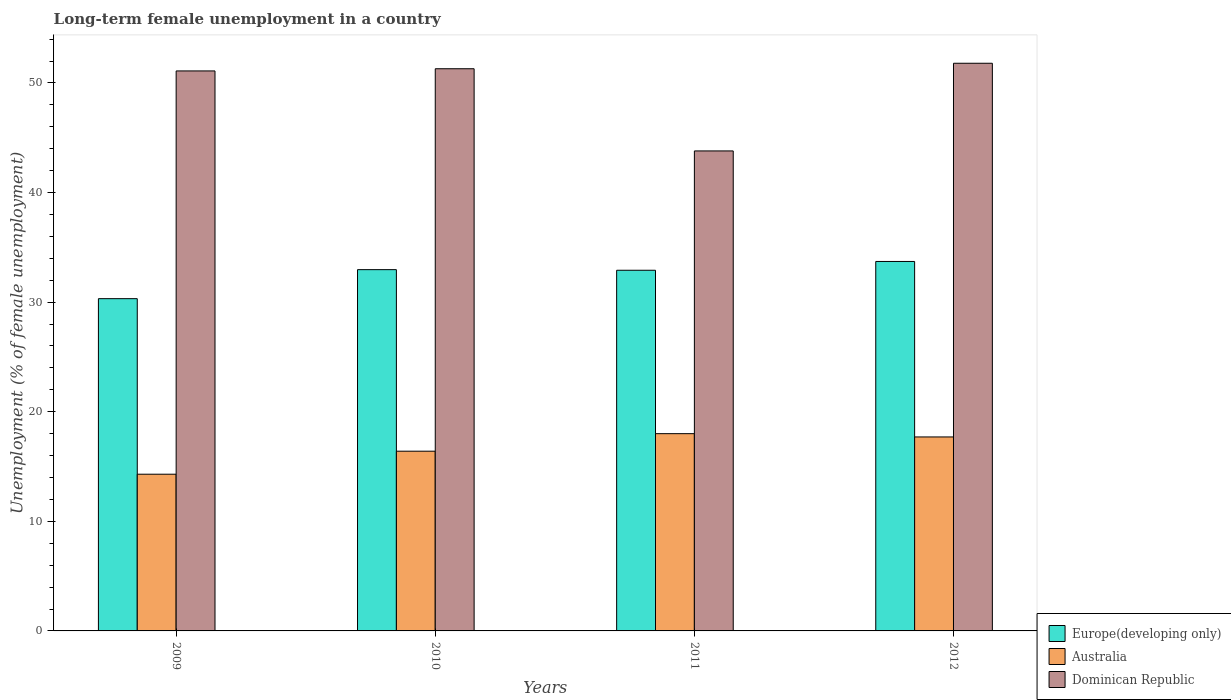How many groups of bars are there?
Provide a succinct answer. 4. Are the number of bars per tick equal to the number of legend labels?
Offer a terse response. Yes. Are the number of bars on each tick of the X-axis equal?
Provide a succinct answer. Yes. How many bars are there on the 3rd tick from the left?
Your answer should be very brief. 3. What is the percentage of long-term unemployed female population in Dominican Republic in 2011?
Give a very brief answer. 43.8. Across all years, what is the maximum percentage of long-term unemployed female population in Australia?
Provide a succinct answer. 18. Across all years, what is the minimum percentage of long-term unemployed female population in Australia?
Offer a terse response. 14.3. In which year was the percentage of long-term unemployed female population in Australia maximum?
Provide a short and direct response. 2011. In which year was the percentage of long-term unemployed female population in Dominican Republic minimum?
Provide a short and direct response. 2011. What is the total percentage of long-term unemployed female population in Dominican Republic in the graph?
Your answer should be very brief. 198. What is the difference between the percentage of long-term unemployed female population in Europe(developing only) in 2009 and that in 2011?
Offer a very short reply. -2.59. What is the difference between the percentage of long-term unemployed female population in Dominican Republic in 2010 and the percentage of long-term unemployed female population in Europe(developing only) in 2012?
Provide a short and direct response. 17.59. What is the average percentage of long-term unemployed female population in Europe(developing only) per year?
Make the answer very short. 32.48. In the year 2011, what is the difference between the percentage of long-term unemployed female population in Dominican Republic and percentage of long-term unemployed female population in Australia?
Offer a very short reply. 25.8. What is the ratio of the percentage of long-term unemployed female population in Europe(developing only) in 2009 to that in 2012?
Your answer should be very brief. 0.9. Is the percentage of long-term unemployed female population in Europe(developing only) in 2009 less than that in 2010?
Your answer should be compact. Yes. What is the difference between the highest and the second highest percentage of long-term unemployed female population in Dominican Republic?
Your answer should be very brief. 0.5. What is the difference between the highest and the lowest percentage of long-term unemployed female population in Europe(developing only)?
Offer a very short reply. 3.4. In how many years, is the percentage of long-term unemployed female population in Australia greater than the average percentage of long-term unemployed female population in Australia taken over all years?
Make the answer very short. 2. Is the sum of the percentage of long-term unemployed female population in Europe(developing only) in 2009 and 2011 greater than the maximum percentage of long-term unemployed female population in Dominican Republic across all years?
Offer a terse response. Yes. What does the 1st bar from the left in 2011 represents?
Give a very brief answer. Europe(developing only). What does the 1st bar from the right in 2012 represents?
Keep it short and to the point. Dominican Republic. Is it the case that in every year, the sum of the percentage of long-term unemployed female population in Australia and percentage of long-term unemployed female population in Dominican Republic is greater than the percentage of long-term unemployed female population in Europe(developing only)?
Give a very brief answer. Yes. How many bars are there?
Provide a short and direct response. 12. Does the graph contain any zero values?
Your answer should be very brief. No. Does the graph contain grids?
Your answer should be compact. No. How many legend labels are there?
Make the answer very short. 3. How are the legend labels stacked?
Provide a succinct answer. Vertical. What is the title of the graph?
Keep it short and to the point. Long-term female unemployment in a country. What is the label or title of the X-axis?
Give a very brief answer. Years. What is the label or title of the Y-axis?
Offer a very short reply. Unemployment (% of female unemployment). What is the Unemployment (% of female unemployment) in Europe(developing only) in 2009?
Your answer should be compact. 30.32. What is the Unemployment (% of female unemployment) in Australia in 2009?
Your answer should be very brief. 14.3. What is the Unemployment (% of female unemployment) of Dominican Republic in 2009?
Offer a very short reply. 51.1. What is the Unemployment (% of female unemployment) of Europe(developing only) in 2010?
Your response must be concise. 32.97. What is the Unemployment (% of female unemployment) of Australia in 2010?
Your response must be concise. 16.4. What is the Unemployment (% of female unemployment) of Dominican Republic in 2010?
Keep it short and to the point. 51.3. What is the Unemployment (% of female unemployment) of Europe(developing only) in 2011?
Offer a terse response. 32.91. What is the Unemployment (% of female unemployment) of Australia in 2011?
Make the answer very short. 18. What is the Unemployment (% of female unemployment) of Dominican Republic in 2011?
Your answer should be very brief. 43.8. What is the Unemployment (% of female unemployment) in Europe(developing only) in 2012?
Give a very brief answer. 33.71. What is the Unemployment (% of female unemployment) of Australia in 2012?
Your answer should be compact. 17.7. What is the Unemployment (% of female unemployment) of Dominican Republic in 2012?
Give a very brief answer. 51.8. Across all years, what is the maximum Unemployment (% of female unemployment) of Europe(developing only)?
Your answer should be compact. 33.71. Across all years, what is the maximum Unemployment (% of female unemployment) of Dominican Republic?
Offer a very short reply. 51.8. Across all years, what is the minimum Unemployment (% of female unemployment) in Europe(developing only)?
Provide a short and direct response. 30.32. Across all years, what is the minimum Unemployment (% of female unemployment) of Australia?
Ensure brevity in your answer.  14.3. Across all years, what is the minimum Unemployment (% of female unemployment) in Dominican Republic?
Your answer should be compact. 43.8. What is the total Unemployment (% of female unemployment) of Europe(developing only) in the graph?
Make the answer very short. 129.91. What is the total Unemployment (% of female unemployment) of Australia in the graph?
Provide a short and direct response. 66.4. What is the total Unemployment (% of female unemployment) in Dominican Republic in the graph?
Provide a succinct answer. 198. What is the difference between the Unemployment (% of female unemployment) in Europe(developing only) in 2009 and that in 2010?
Keep it short and to the point. -2.65. What is the difference between the Unemployment (% of female unemployment) in Australia in 2009 and that in 2010?
Offer a very short reply. -2.1. What is the difference between the Unemployment (% of female unemployment) of Europe(developing only) in 2009 and that in 2011?
Offer a terse response. -2.59. What is the difference between the Unemployment (% of female unemployment) in Australia in 2009 and that in 2011?
Offer a terse response. -3.7. What is the difference between the Unemployment (% of female unemployment) in Europe(developing only) in 2009 and that in 2012?
Offer a very short reply. -3.4. What is the difference between the Unemployment (% of female unemployment) in Europe(developing only) in 2010 and that in 2011?
Provide a short and direct response. 0.06. What is the difference between the Unemployment (% of female unemployment) in Australia in 2010 and that in 2011?
Your answer should be compact. -1.6. What is the difference between the Unemployment (% of female unemployment) of Europe(developing only) in 2010 and that in 2012?
Give a very brief answer. -0.75. What is the difference between the Unemployment (% of female unemployment) in Europe(developing only) in 2011 and that in 2012?
Your answer should be very brief. -0.8. What is the difference between the Unemployment (% of female unemployment) of Dominican Republic in 2011 and that in 2012?
Provide a succinct answer. -8. What is the difference between the Unemployment (% of female unemployment) of Europe(developing only) in 2009 and the Unemployment (% of female unemployment) of Australia in 2010?
Provide a succinct answer. 13.92. What is the difference between the Unemployment (% of female unemployment) in Europe(developing only) in 2009 and the Unemployment (% of female unemployment) in Dominican Republic in 2010?
Give a very brief answer. -20.98. What is the difference between the Unemployment (% of female unemployment) of Australia in 2009 and the Unemployment (% of female unemployment) of Dominican Republic in 2010?
Provide a short and direct response. -37. What is the difference between the Unemployment (% of female unemployment) in Europe(developing only) in 2009 and the Unemployment (% of female unemployment) in Australia in 2011?
Your answer should be compact. 12.32. What is the difference between the Unemployment (% of female unemployment) of Europe(developing only) in 2009 and the Unemployment (% of female unemployment) of Dominican Republic in 2011?
Offer a very short reply. -13.48. What is the difference between the Unemployment (% of female unemployment) in Australia in 2009 and the Unemployment (% of female unemployment) in Dominican Republic in 2011?
Provide a succinct answer. -29.5. What is the difference between the Unemployment (% of female unemployment) in Europe(developing only) in 2009 and the Unemployment (% of female unemployment) in Australia in 2012?
Keep it short and to the point. 12.62. What is the difference between the Unemployment (% of female unemployment) in Europe(developing only) in 2009 and the Unemployment (% of female unemployment) in Dominican Republic in 2012?
Make the answer very short. -21.48. What is the difference between the Unemployment (% of female unemployment) of Australia in 2009 and the Unemployment (% of female unemployment) of Dominican Republic in 2012?
Ensure brevity in your answer.  -37.5. What is the difference between the Unemployment (% of female unemployment) of Europe(developing only) in 2010 and the Unemployment (% of female unemployment) of Australia in 2011?
Provide a succinct answer. 14.97. What is the difference between the Unemployment (% of female unemployment) in Europe(developing only) in 2010 and the Unemployment (% of female unemployment) in Dominican Republic in 2011?
Your answer should be very brief. -10.83. What is the difference between the Unemployment (% of female unemployment) in Australia in 2010 and the Unemployment (% of female unemployment) in Dominican Republic in 2011?
Offer a terse response. -27.4. What is the difference between the Unemployment (% of female unemployment) of Europe(developing only) in 2010 and the Unemployment (% of female unemployment) of Australia in 2012?
Your answer should be compact. 15.27. What is the difference between the Unemployment (% of female unemployment) in Europe(developing only) in 2010 and the Unemployment (% of female unemployment) in Dominican Republic in 2012?
Make the answer very short. -18.83. What is the difference between the Unemployment (% of female unemployment) in Australia in 2010 and the Unemployment (% of female unemployment) in Dominican Republic in 2012?
Your answer should be compact. -35.4. What is the difference between the Unemployment (% of female unemployment) in Europe(developing only) in 2011 and the Unemployment (% of female unemployment) in Australia in 2012?
Your answer should be very brief. 15.21. What is the difference between the Unemployment (% of female unemployment) in Europe(developing only) in 2011 and the Unemployment (% of female unemployment) in Dominican Republic in 2012?
Provide a succinct answer. -18.89. What is the difference between the Unemployment (% of female unemployment) in Australia in 2011 and the Unemployment (% of female unemployment) in Dominican Republic in 2012?
Your answer should be very brief. -33.8. What is the average Unemployment (% of female unemployment) of Europe(developing only) per year?
Your answer should be compact. 32.48. What is the average Unemployment (% of female unemployment) in Dominican Republic per year?
Make the answer very short. 49.5. In the year 2009, what is the difference between the Unemployment (% of female unemployment) in Europe(developing only) and Unemployment (% of female unemployment) in Australia?
Offer a very short reply. 16.02. In the year 2009, what is the difference between the Unemployment (% of female unemployment) of Europe(developing only) and Unemployment (% of female unemployment) of Dominican Republic?
Ensure brevity in your answer.  -20.78. In the year 2009, what is the difference between the Unemployment (% of female unemployment) in Australia and Unemployment (% of female unemployment) in Dominican Republic?
Your response must be concise. -36.8. In the year 2010, what is the difference between the Unemployment (% of female unemployment) of Europe(developing only) and Unemployment (% of female unemployment) of Australia?
Ensure brevity in your answer.  16.57. In the year 2010, what is the difference between the Unemployment (% of female unemployment) of Europe(developing only) and Unemployment (% of female unemployment) of Dominican Republic?
Ensure brevity in your answer.  -18.33. In the year 2010, what is the difference between the Unemployment (% of female unemployment) in Australia and Unemployment (% of female unemployment) in Dominican Republic?
Make the answer very short. -34.9. In the year 2011, what is the difference between the Unemployment (% of female unemployment) of Europe(developing only) and Unemployment (% of female unemployment) of Australia?
Ensure brevity in your answer.  14.91. In the year 2011, what is the difference between the Unemployment (% of female unemployment) in Europe(developing only) and Unemployment (% of female unemployment) in Dominican Republic?
Offer a very short reply. -10.89. In the year 2011, what is the difference between the Unemployment (% of female unemployment) of Australia and Unemployment (% of female unemployment) of Dominican Republic?
Provide a succinct answer. -25.8. In the year 2012, what is the difference between the Unemployment (% of female unemployment) in Europe(developing only) and Unemployment (% of female unemployment) in Australia?
Provide a short and direct response. 16.01. In the year 2012, what is the difference between the Unemployment (% of female unemployment) of Europe(developing only) and Unemployment (% of female unemployment) of Dominican Republic?
Make the answer very short. -18.09. In the year 2012, what is the difference between the Unemployment (% of female unemployment) of Australia and Unemployment (% of female unemployment) of Dominican Republic?
Provide a succinct answer. -34.1. What is the ratio of the Unemployment (% of female unemployment) in Europe(developing only) in 2009 to that in 2010?
Your response must be concise. 0.92. What is the ratio of the Unemployment (% of female unemployment) of Australia in 2009 to that in 2010?
Your answer should be compact. 0.87. What is the ratio of the Unemployment (% of female unemployment) in Europe(developing only) in 2009 to that in 2011?
Give a very brief answer. 0.92. What is the ratio of the Unemployment (% of female unemployment) in Australia in 2009 to that in 2011?
Make the answer very short. 0.79. What is the ratio of the Unemployment (% of female unemployment) in Europe(developing only) in 2009 to that in 2012?
Make the answer very short. 0.9. What is the ratio of the Unemployment (% of female unemployment) in Australia in 2009 to that in 2012?
Provide a short and direct response. 0.81. What is the ratio of the Unemployment (% of female unemployment) of Dominican Republic in 2009 to that in 2012?
Your response must be concise. 0.99. What is the ratio of the Unemployment (% of female unemployment) of Australia in 2010 to that in 2011?
Keep it short and to the point. 0.91. What is the ratio of the Unemployment (% of female unemployment) of Dominican Republic in 2010 to that in 2011?
Provide a succinct answer. 1.17. What is the ratio of the Unemployment (% of female unemployment) of Europe(developing only) in 2010 to that in 2012?
Give a very brief answer. 0.98. What is the ratio of the Unemployment (% of female unemployment) in Australia in 2010 to that in 2012?
Your answer should be very brief. 0.93. What is the ratio of the Unemployment (% of female unemployment) of Dominican Republic in 2010 to that in 2012?
Ensure brevity in your answer.  0.99. What is the ratio of the Unemployment (% of female unemployment) of Europe(developing only) in 2011 to that in 2012?
Offer a terse response. 0.98. What is the ratio of the Unemployment (% of female unemployment) of Australia in 2011 to that in 2012?
Offer a terse response. 1.02. What is the ratio of the Unemployment (% of female unemployment) in Dominican Republic in 2011 to that in 2012?
Your answer should be compact. 0.85. What is the difference between the highest and the second highest Unemployment (% of female unemployment) of Europe(developing only)?
Offer a very short reply. 0.75. What is the difference between the highest and the second highest Unemployment (% of female unemployment) in Australia?
Keep it short and to the point. 0.3. What is the difference between the highest and the second highest Unemployment (% of female unemployment) in Dominican Republic?
Provide a succinct answer. 0.5. What is the difference between the highest and the lowest Unemployment (% of female unemployment) of Europe(developing only)?
Give a very brief answer. 3.4. What is the difference between the highest and the lowest Unemployment (% of female unemployment) of Australia?
Offer a terse response. 3.7. 